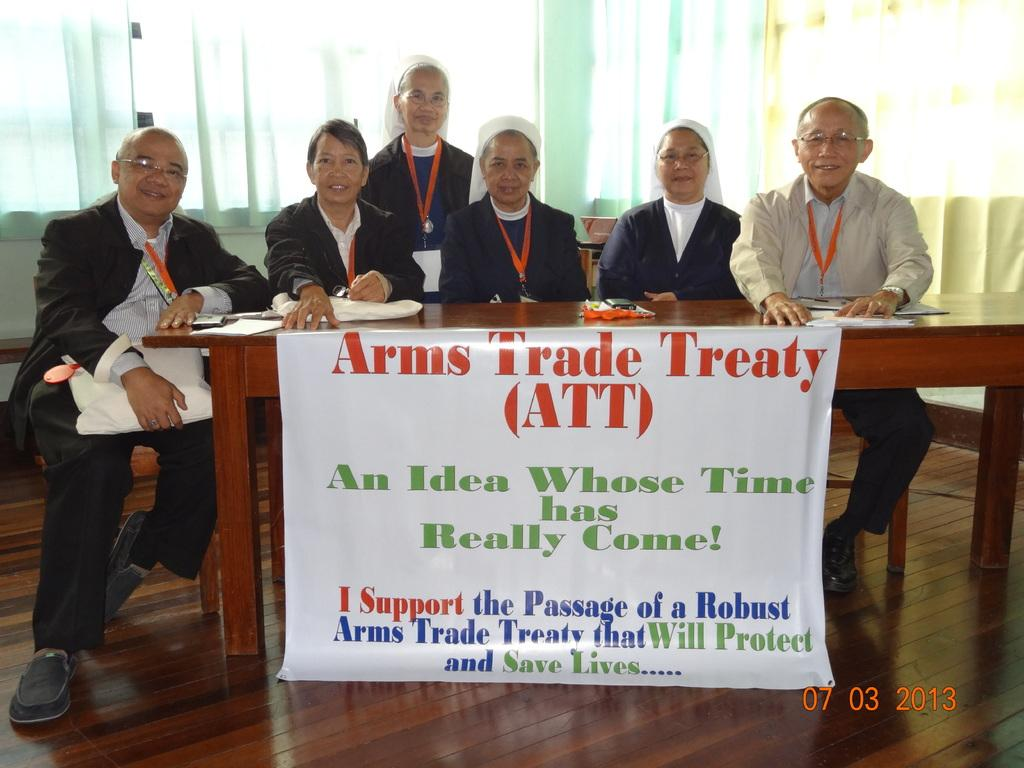What type of view is shown in the image? The image is an inside view. What are the people in the image doing? The people are sitting on chairs in the image. Where are the chairs located in relation to the table? The chairs are in front of a table. What is placed on the table in the image? A banner is placed on the table. What can be seen in the background of the image? There are curtains visible in the background of the image. How many pots can be seen on the table in the image? There are no pots visible on the table in the image. What type of lizards are crawling on the curtains in the background? There are no lizards present in the image, and therefore no such activity can be observed. 